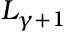Convert formula to latex. <formula><loc_0><loc_0><loc_500><loc_500>L _ { \gamma + 1 }</formula> 